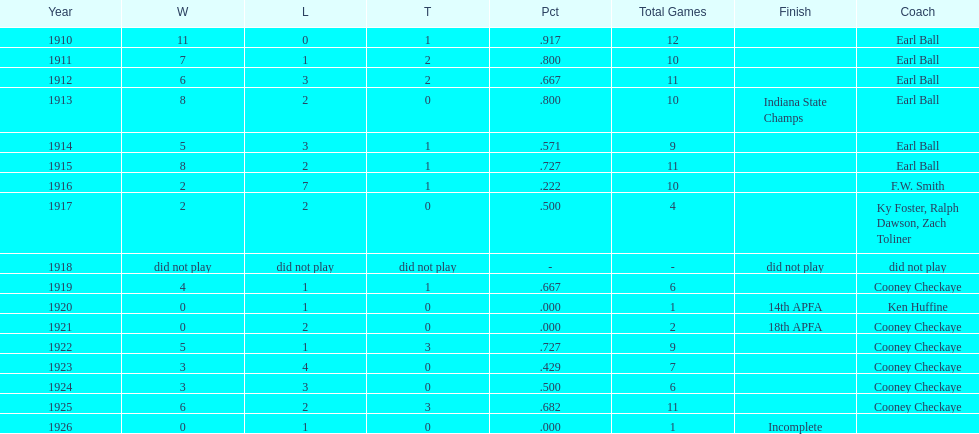How many years did earl ball coach the muncie flyers? 6. 